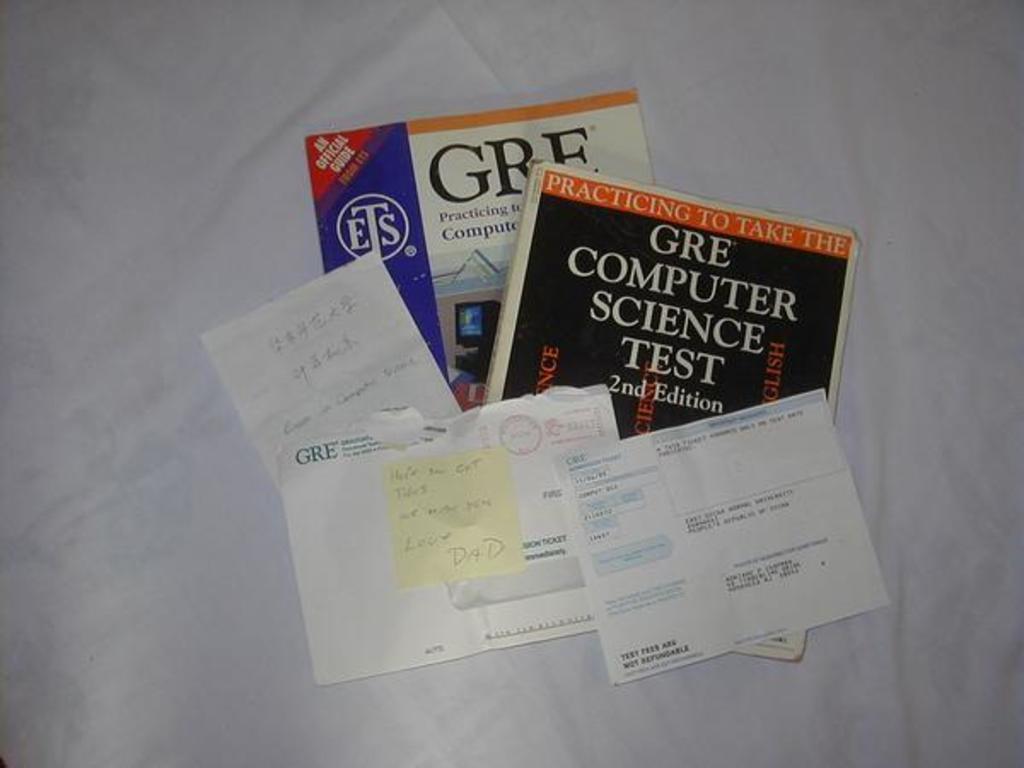What edition is the computer science test book?
Offer a very short reply. 2nd. What test are these study guides for?
Give a very brief answer. Gre. 